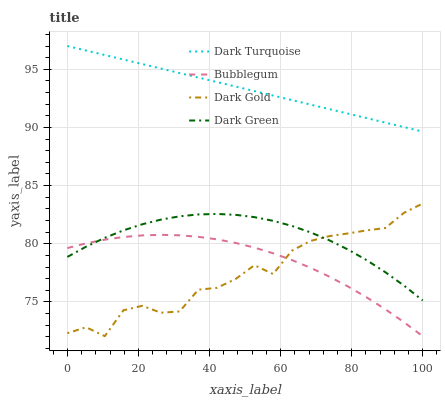Does Dark Gold have the minimum area under the curve?
Answer yes or no. Yes. Does Dark Turquoise have the maximum area under the curve?
Answer yes or no. Yes. Does Dark Green have the minimum area under the curve?
Answer yes or no. No. Does Dark Green have the maximum area under the curve?
Answer yes or no. No. Is Dark Turquoise the smoothest?
Answer yes or no. Yes. Is Dark Gold the roughest?
Answer yes or no. Yes. Is Dark Green the smoothest?
Answer yes or no. No. Is Dark Green the roughest?
Answer yes or no. No. Does Bubblegum have the lowest value?
Answer yes or no. Yes. Does Dark Green have the lowest value?
Answer yes or no. No. Does Dark Turquoise have the highest value?
Answer yes or no. Yes. Does Dark Green have the highest value?
Answer yes or no. No. Is Dark Gold less than Dark Turquoise?
Answer yes or no. Yes. Is Dark Turquoise greater than Dark Green?
Answer yes or no. Yes. Does Bubblegum intersect Dark Gold?
Answer yes or no. Yes. Is Bubblegum less than Dark Gold?
Answer yes or no. No. Is Bubblegum greater than Dark Gold?
Answer yes or no. No. Does Dark Gold intersect Dark Turquoise?
Answer yes or no. No. 